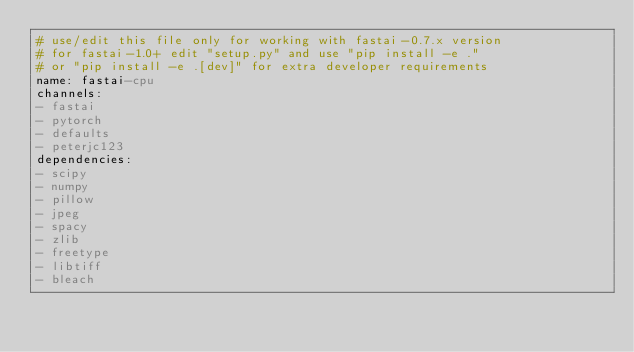<code> <loc_0><loc_0><loc_500><loc_500><_YAML_># use/edit this file only for working with fastai-0.7.x version
# for fastai-1.0+ edit "setup.py" and use "pip install -e ."
# or "pip install -e .[dev]" for extra developer requirements
name: fastai-cpu
channels:
- fastai
- pytorch
- defaults
- peterjc123
dependencies:
- scipy
- numpy
- pillow
- jpeg
- spacy
- zlib
- freetype
- libtiff
- bleach</code> 